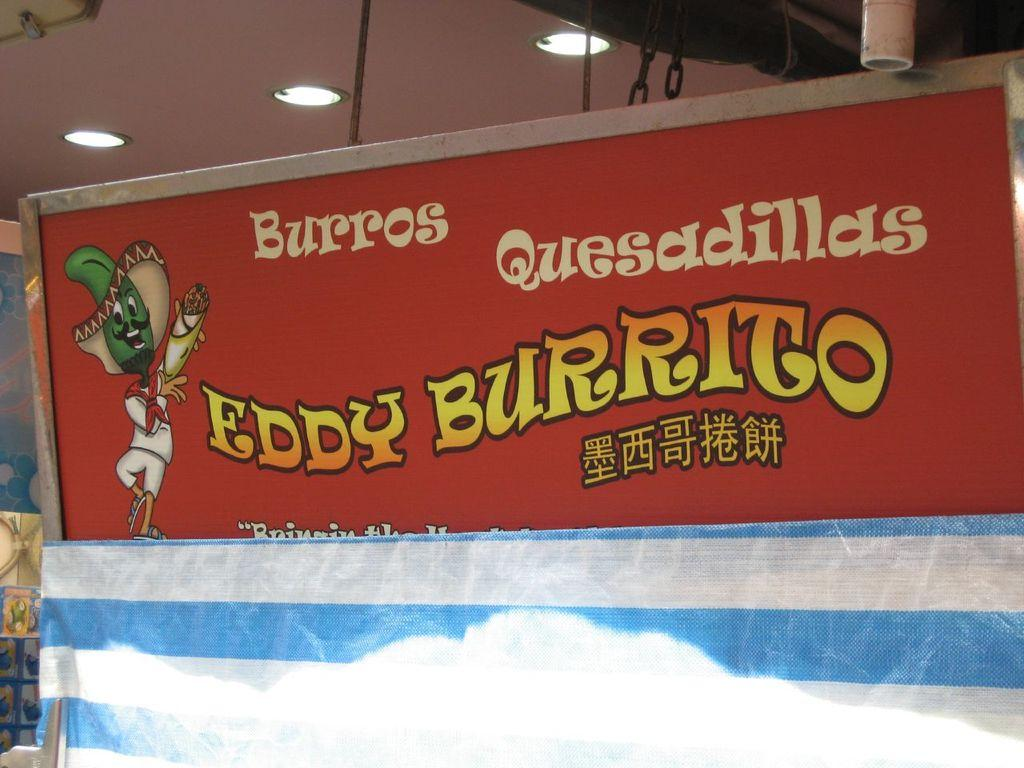<image>
Share a concise interpretation of the image provided. A red sign advertising Eddy Burrito in three different languages. 